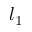Convert formula to latex. <formula><loc_0><loc_0><loc_500><loc_500>l _ { 1 }</formula> 